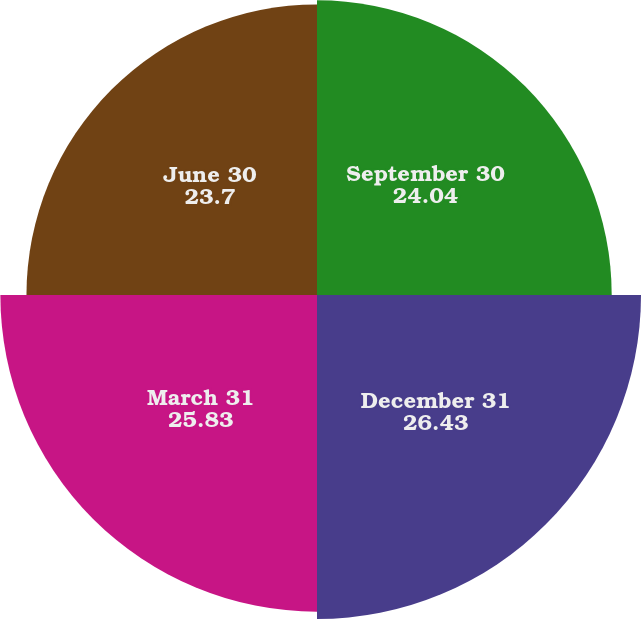Convert chart to OTSL. <chart><loc_0><loc_0><loc_500><loc_500><pie_chart><fcel>September 30<fcel>December 31<fcel>March 31<fcel>June 30<nl><fcel>24.04%<fcel>26.43%<fcel>25.83%<fcel>23.7%<nl></chart> 